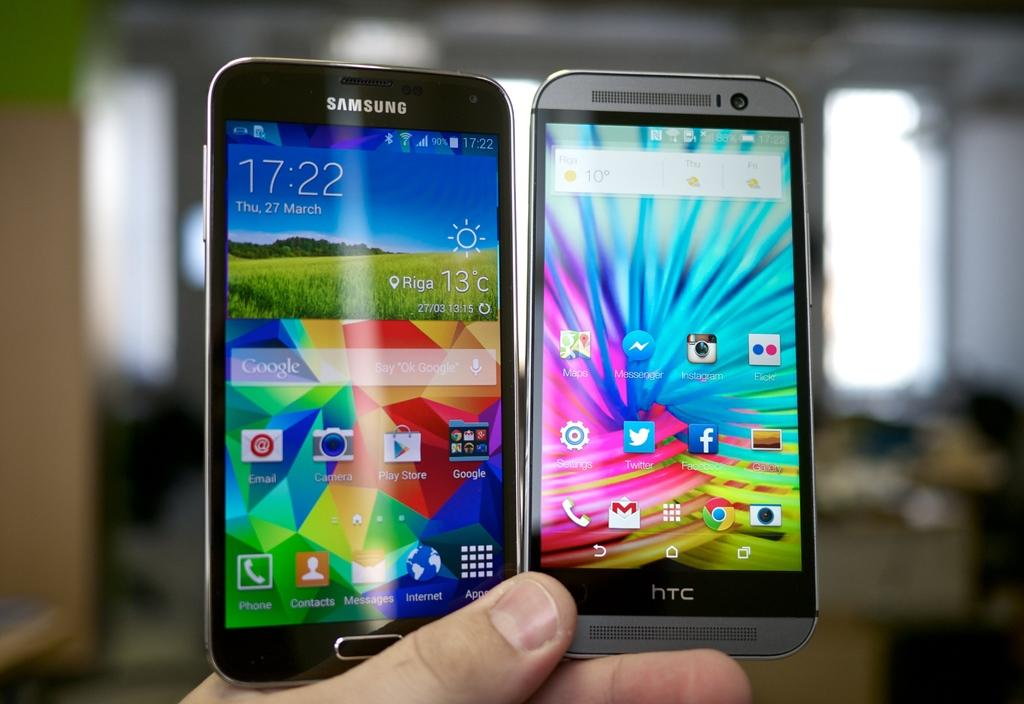<image>
Relay a brief, clear account of the picture shown. a person is holding a samsung and an HTC phone in their hands 